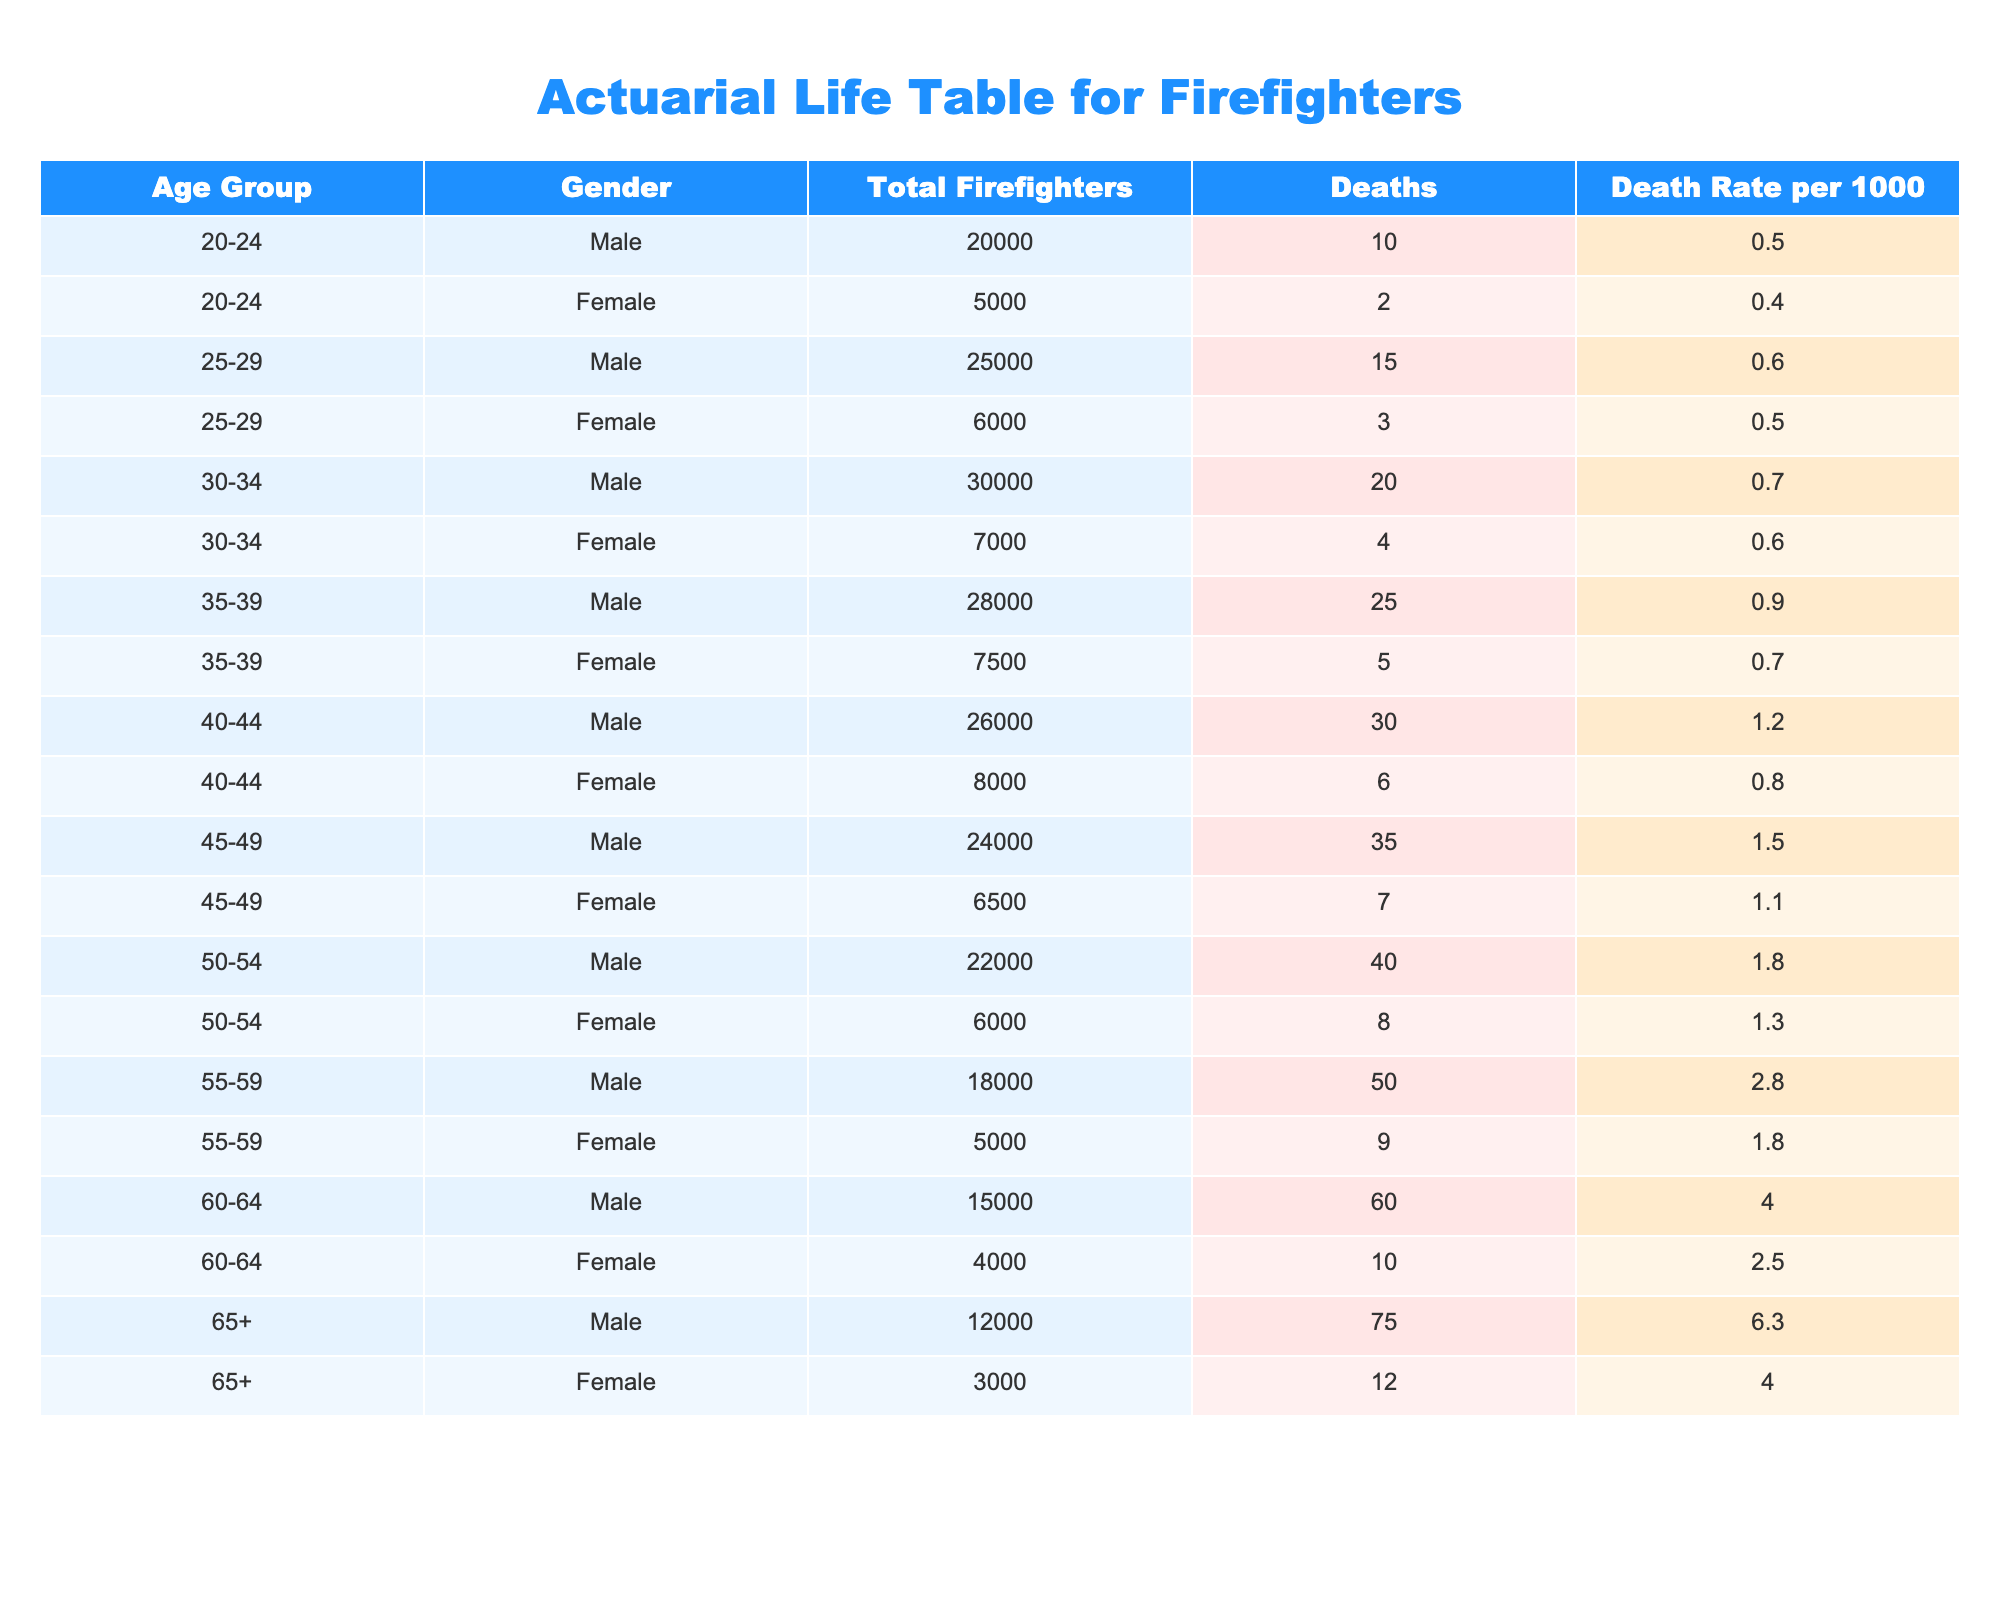What is the death rate for male firefighters aged 50-54? Referring to the table, the death rate for male firefighters in the age group 50-54 is listed as 1.8 per 1000.
Answer: 1.8 What is the total number of female firefighters aged 40-44? In the table, the total number of female firefighters in the age group 40-44 is provided as 8000.
Answer: 8000 Which age group has the highest death rate for male firefighters? To determine this, we need to check all age groups for male firefighters. The highest death rate is in the age group 65+, which is 6.3 per 1000.
Answer: 65+ Is the death rate for female firefighters higher in the 60-64 age group compared to the 55-59 age group? Looking at the table, the death rate for females aged 60-64 is 2.5 per 1000, while for 55-59, it is 1.8 per 1000. Since 2.5 is greater than 1.8, the death rate for the 60-64 age group is indeed higher.
Answer: Yes What is the average death rate for male firefighters in the age groups 45-49 and 50-54? The death rates for males in these age groups are 1.5 (45-49) and 1.8 (50-54). To find the average, we sum both rates (1.5 + 1.8 = 3.3) and divide by 2, which gives us 3.3 / 2 = 1.65.
Answer: 1.65 How many deaths occurred among male firefighters in the age group 35-39? The table indicates that the number of deaths for male firefighters aged 35-39 is recorded as 25.
Answer: 25 Is the death rate for female firefighters consistently lower than that of male firefighters across all age groups? Examining the table, we can compare each corresponding age group. In several groups, female death rates are lower, but in some age groups, especially 60-64 and 65+, they are significantly lower too, thus making it generally true.
Answer: Yes What is the combined total of all male firefighters across all age groups? To calculate this, add the total number of male firefighters from each age group: 20000 + 25000 + 30000 + 28000 + 26000 + 24000 + 22000 + 18000 + 15000 + 12000 = 198000.
Answer: 198000 What age group shows the largest number of deaths among female firefighters? In reviewing the table for female firefighters, the highest number of deaths is in the 55-59 age group, with 9 deaths.
Answer: 55-59 